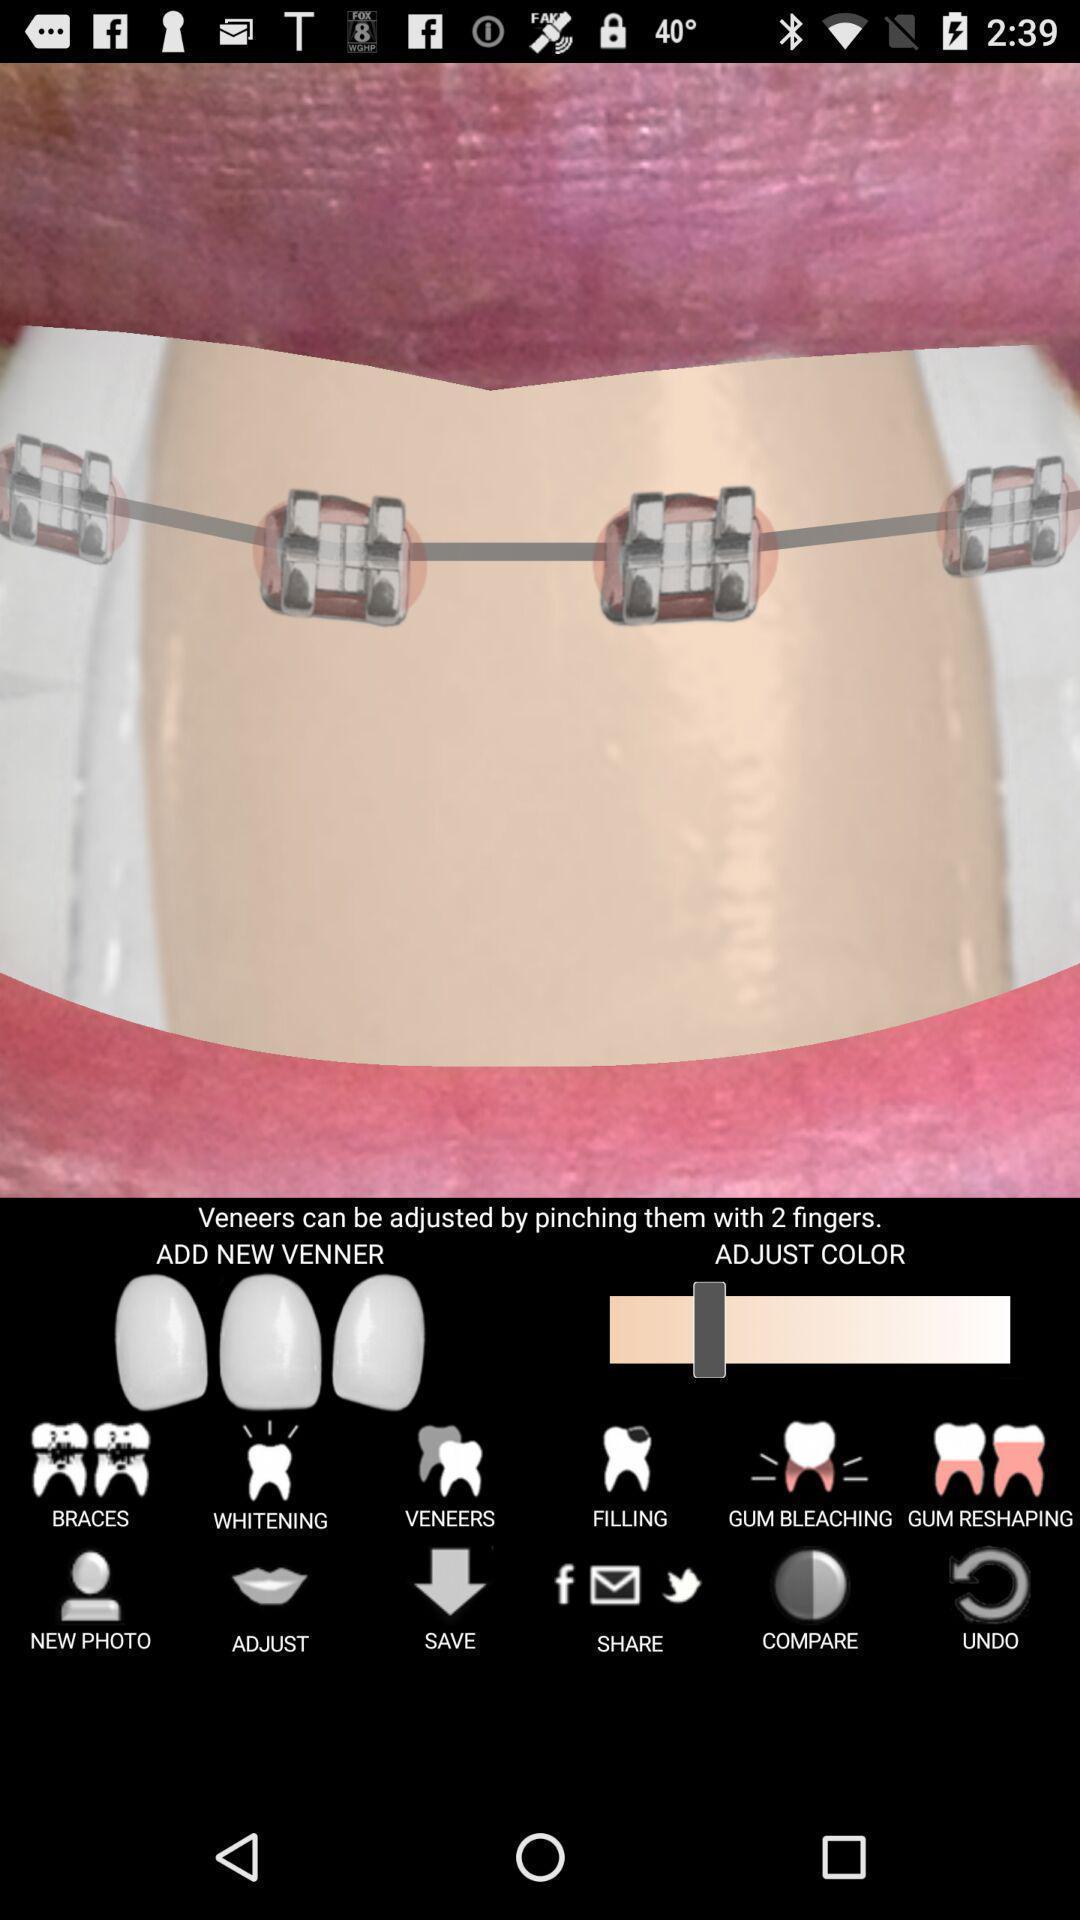Provide a detailed account of this screenshot. Screen shows a teeth image with edit optons. 